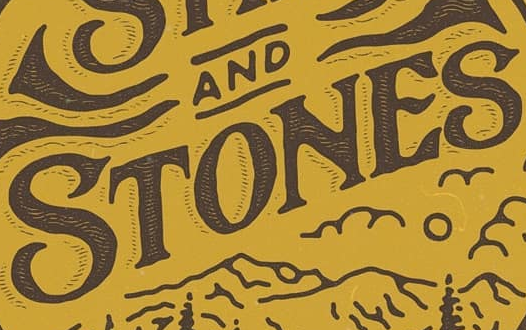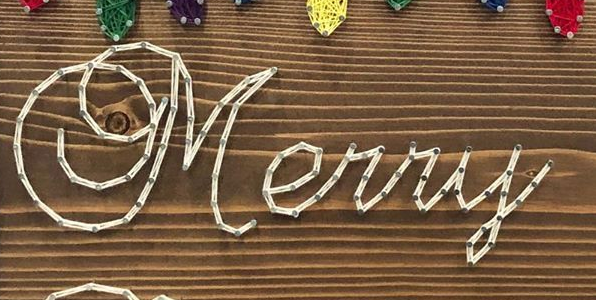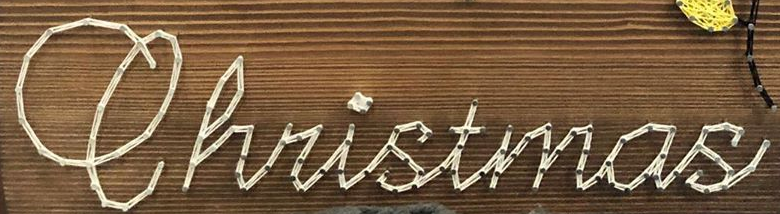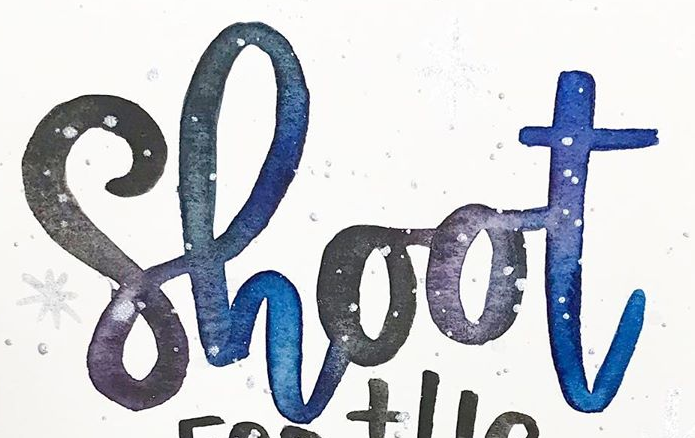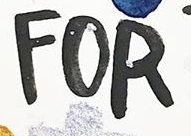What words can you see in these images in sequence, separated by a semicolon? STONES; Merry; Christmas; Shoot; FOR 